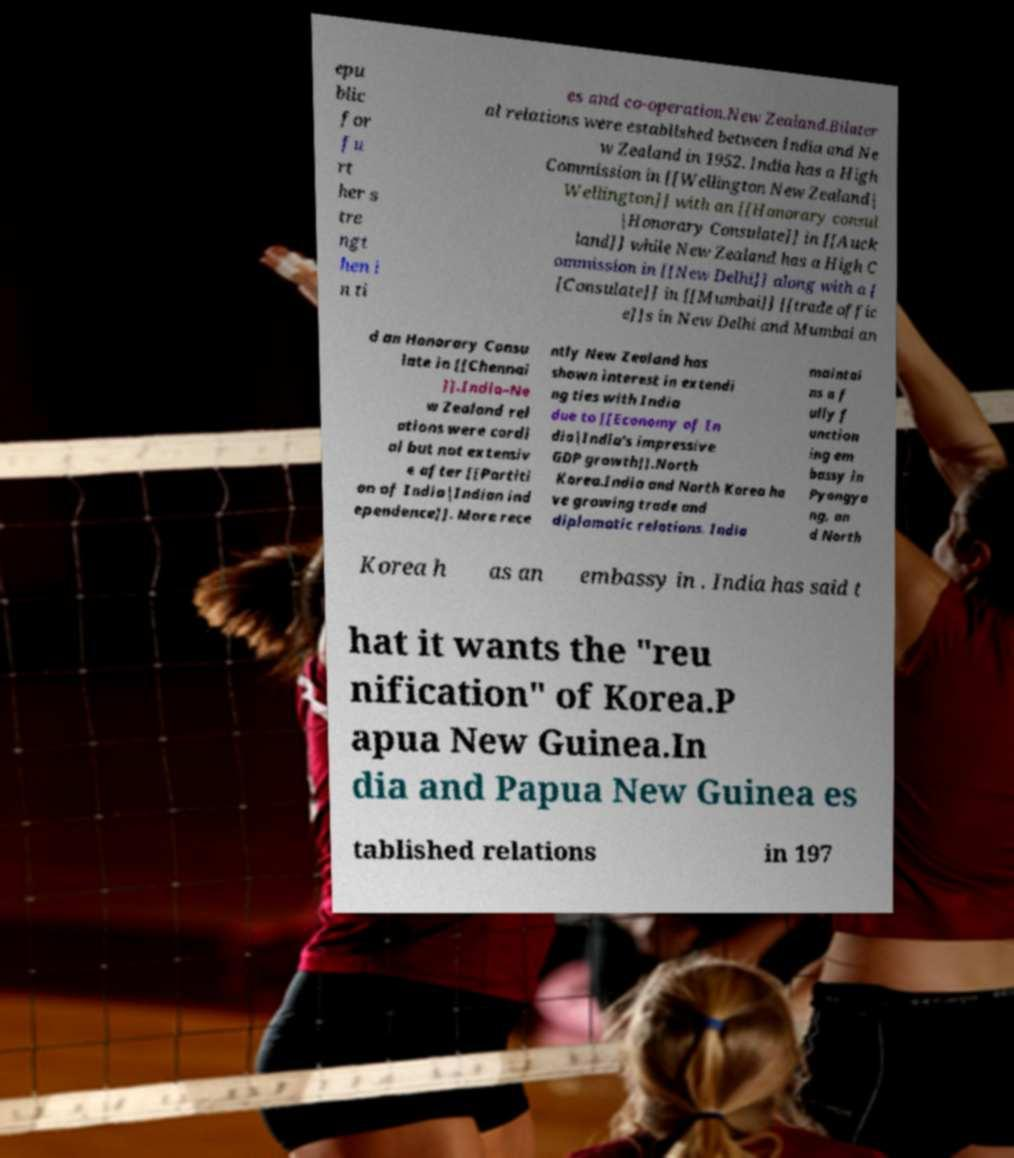What messages or text are displayed in this image? I need them in a readable, typed format. epu blic for fu rt her s tre ngt hen i n ti es and co-operation.New Zealand.Bilater al relations were established between India and Ne w Zealand in 1952. India has a High Commission in [[Wellington New Zealand| Wellington]] with an [[Honorary consul |Honorary Consulate]] in [[Auck land]] while New Zealand has a High C ommission in [[New Delhi]] along with a [ [Consulate]] in [[Mumbai]] [[trade offic e]]s in New Delhi and Mumbai an d an Honorary Consu late in [[Chennai ]].India–Ne w Zealand rel ations were cordi al but not extensiv e after [[Partiti on of India|Indian ind ependence]]. More rece ntly New Zealand has shown interest in extendi ng ties with India due to [[Economy of In dia|India's impressive GDP growth]].North Korea.India and North Korea ha ve growing trade and diplomatic relations. India maintai ns a f ully f unction ing em bassy in Pyongya ng, an d North Korea h as an embassy in . India has said t hat it wants the "reu nification" of Korea.P apua New Guinea.In dia and Papua New Guinea es tablished relations in 197 